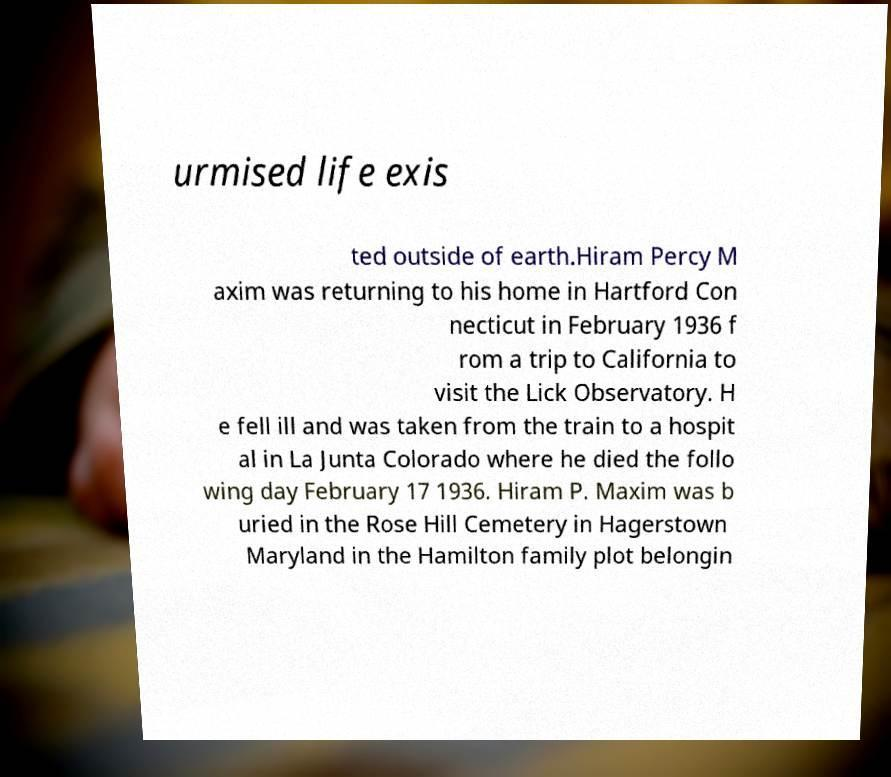Can you accurately transcribe the text from the provided image for me? urmised life exis ted outside of earth.Hiram Percy M axim was returning to his home in Hartford Con necticut in February 1936 f rom a trip to California to visit the Lick Observatory. H e fell ill and was taken from the train to a hospit al in La Junta Colorado where he died the follo wing day February 17 1936. Hiram P. Maxim was b uried in the Rose Hill Cemetery in Hagerstown Maryland in the Hamilton family plot belongin 